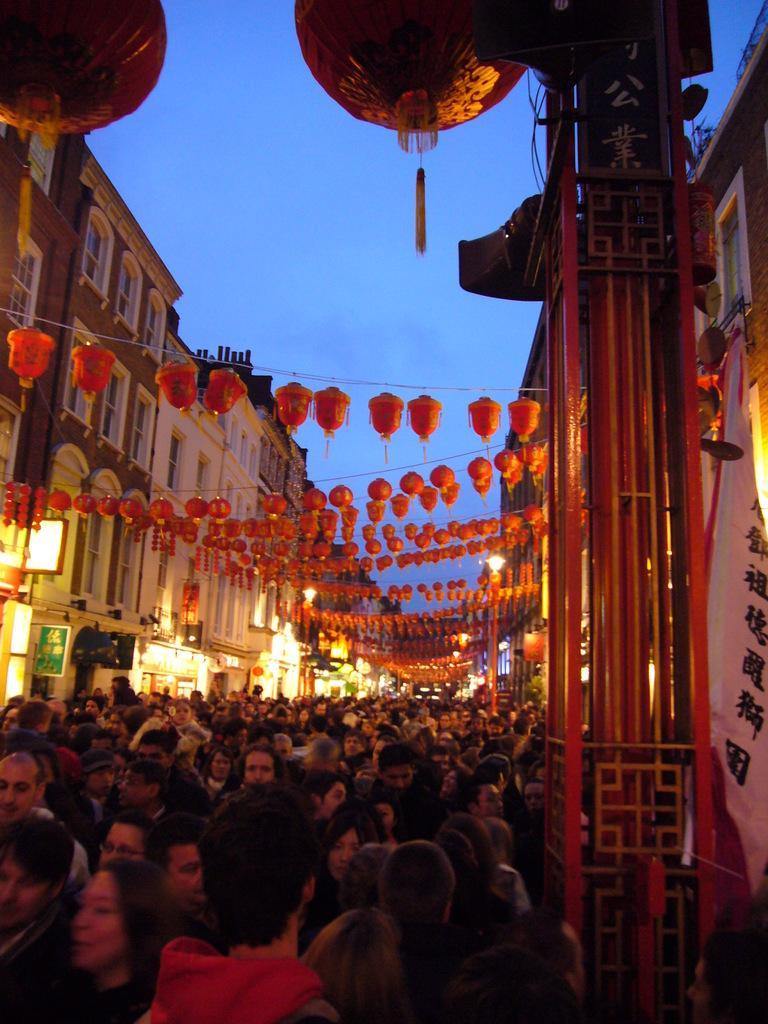Can you describe this image briefly? In this image at the bottom there are a group of people, and on the right side of the image there is a pole and some banners. And in the center of the image there are some lights, and ropes and on the right side and left side there are buildings, lights, boards and poles. At the top there is sky and also we could see some ball like objects. 